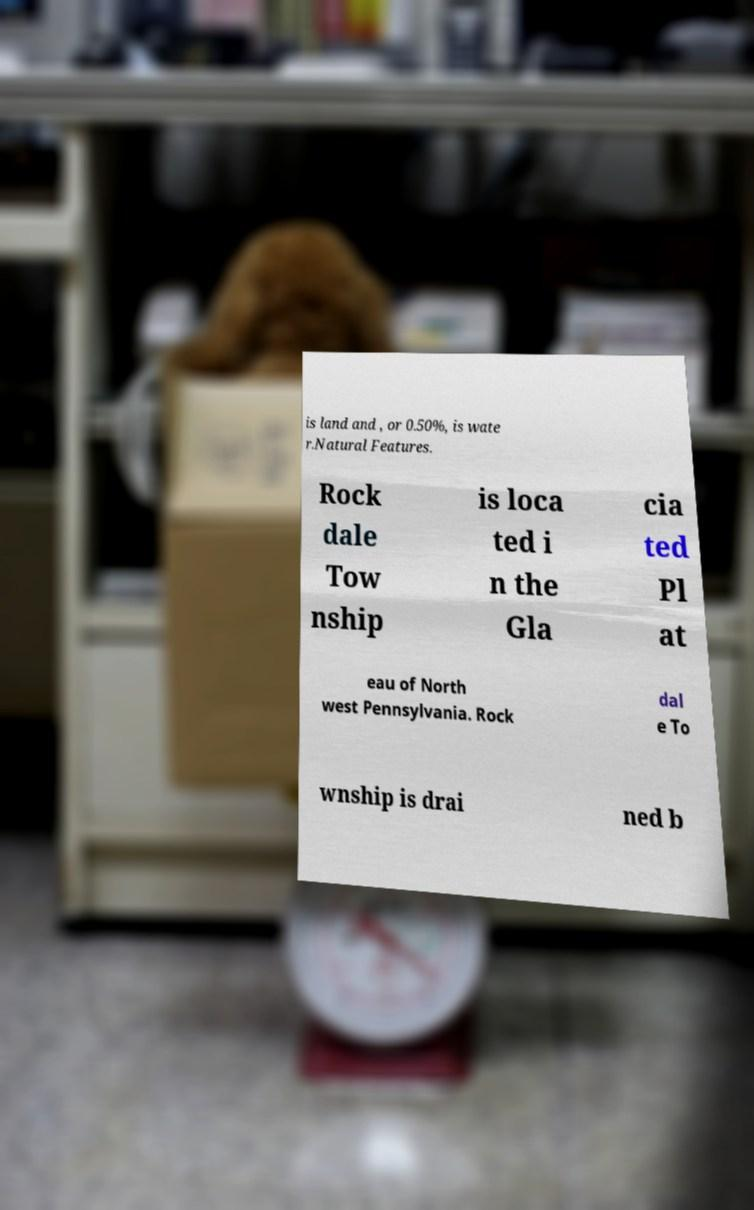I need the written content from this picture converted into text. Can you do that? is land and , or 0.50%, is wate r.Natural Features. Rock dale Tow nship is loca ted i n the Gla cia ted Pl at eau of North west Pennsylvania. Rock dal e To wnship is drai ned b 